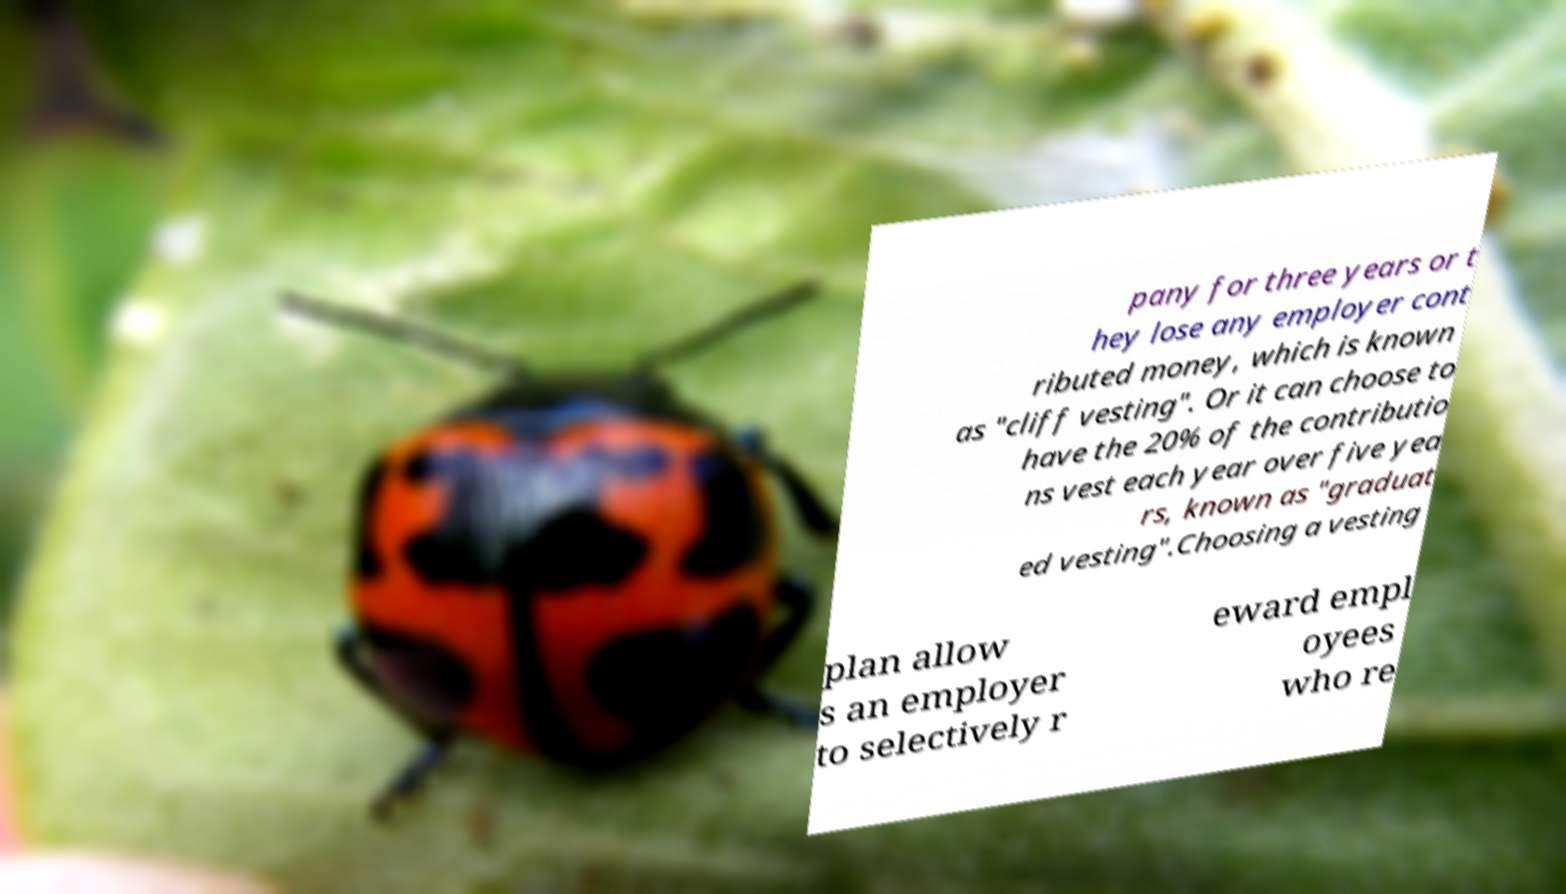Please read and relay the text visible in this image. What does it say? pany for three years or t hey lose any employer cont ributed money, which is known as "cliff vesting". Or it can choose to have the 20% of the contributio ns vest each year over five yea rs, known as "graduat ed vesting".Choosing a vesting plan allow s an employer to selectively r eward empl oyees who re 